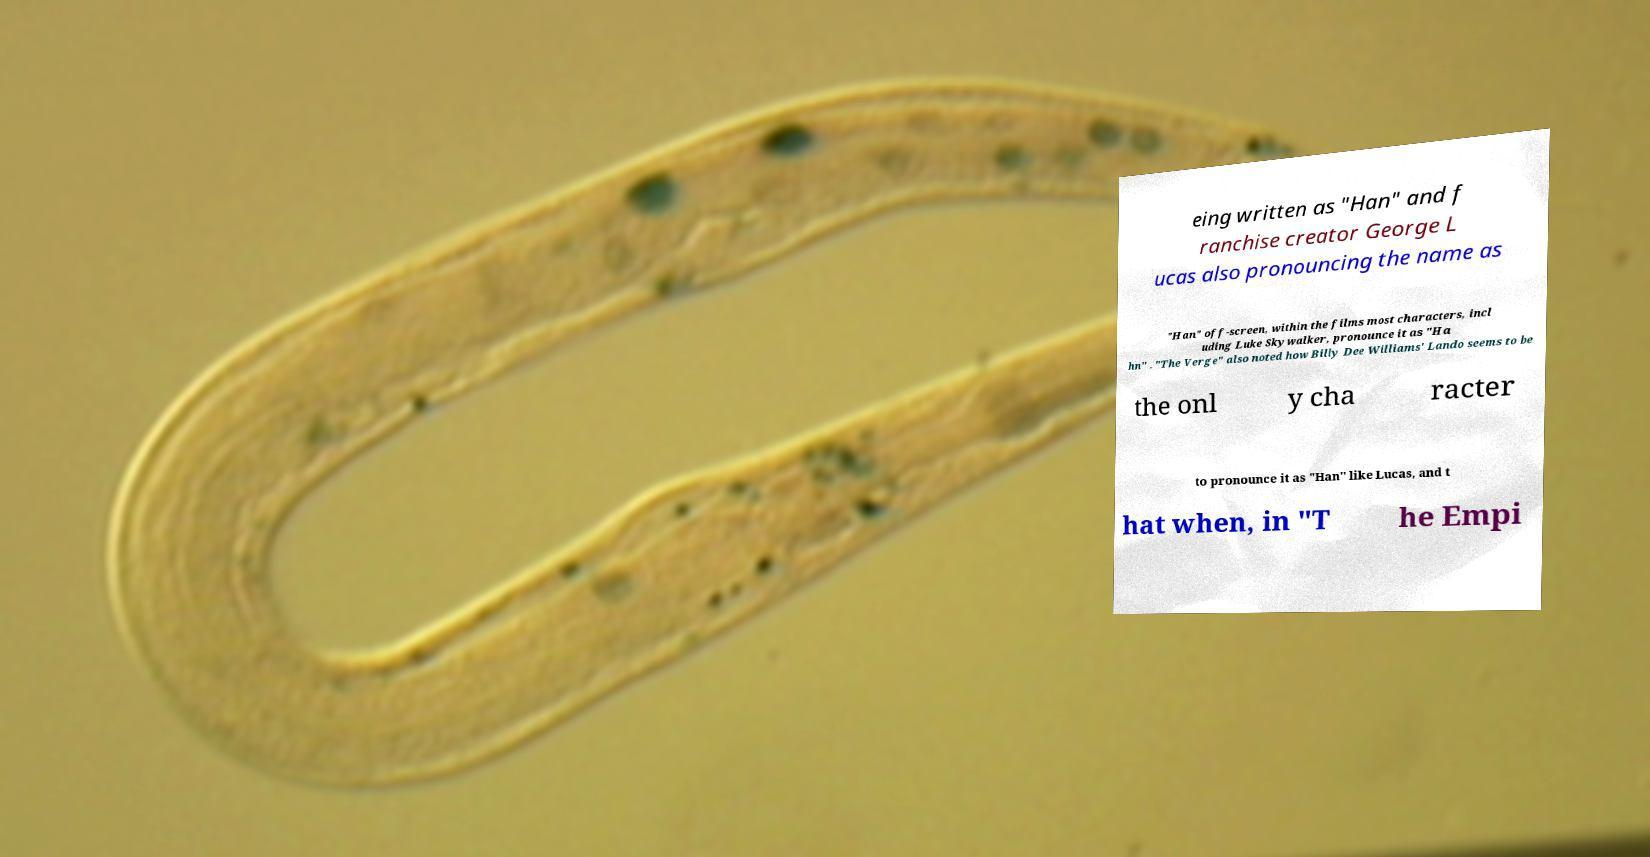Please read and relay the text visible in this image. What does it say? eing written as "Han" and f ranchise creator George L ucas also pronouncing the name as "Han" off-screen, within the films most characters, incl uding Luke Skywalker, pronounce it as "Ha hn" . "The Verge" also noted how Billy Dee Williams' Lando seems to be the onl y cha racter to pronounce it as "Han" like Lucas, and t hat when, in "T he Empi 